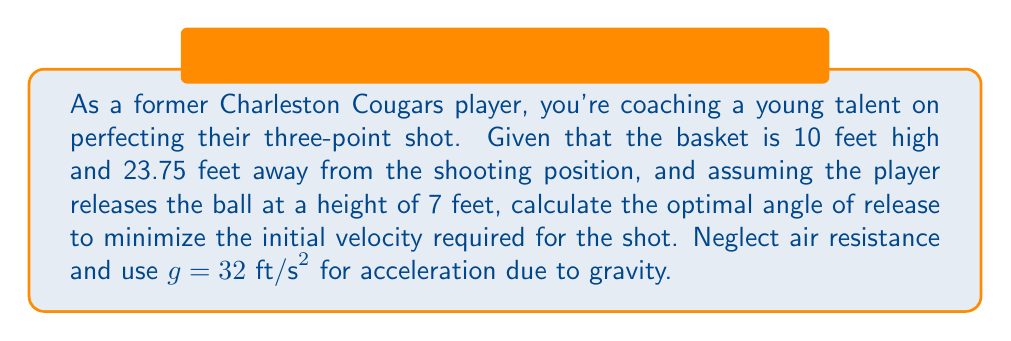Show me your answer to this math problem. Let's approach this step-by-step using calculus:

1) First, we need to set up our coordinate system. Let's use $x$ for horizontal distance and $y$ for vertical distance. The initial position is $(0,7)$ and the final position is $(23.75,10)$.

2) The trajectory of a projectile (neglecting air resistance) is given by:

   $$y = \tan(\theta)x - \frac{gx^2}{2v_0^2\cos^2(\theta)} + y_0$$

   Where $\theta$ is the angle of release, $v_0$ is the initial velocity, and $y_0$ is the initial height.

3) We can find the relationship between $v_0$ and $\theta$ by substituting the final position:

   $$10 = 23.75\tan(\theta) - \frac{32(23.75)^2}{2v_0^2\cos^2(\theta)} + 7$$

4) Solving for $v_0$:

   $$v_0 = \sqrt{\frac{32(23.75)^2}{2\cos^2(\theta)(23.75\tan(\theta) - 3)}}$$

5) To minimize $v_0$, we need to maximize the denominator. Let's call the denominator $f(\theta)$:

   $$f(\theta) = \cos^2(\theta)(23.75\tan(\theta) - 3)$$

6) To find the maximum, we differentiate $f(\theta)$ and set it to zero:

   $$f'(\theta) = -2\cos(\theta)\sin(\theta)(23.75\tan(\theta) - 3) + 23.75\cos^2(\theta)\sec^2(\theta) = 0$$

7) Simplifying and solving this equation gives us the optimal angle:

   $$\theta \approx 47.4^\circ$$

8) This angle minimizes the initial velocity required for the shot.
Answer: $47.4^\circ$ 